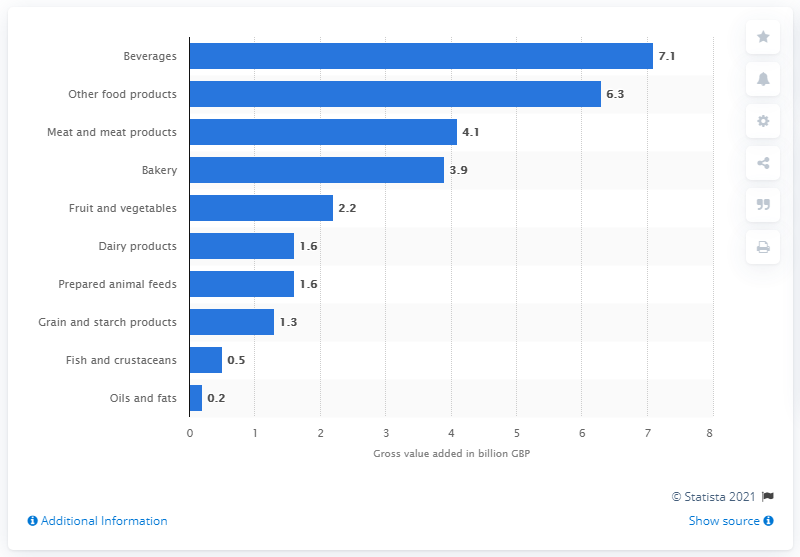Point out several critical features in this image. In 2018, the beverage industry generated a total Gross Value Added (GVA) of 7.1% of the total GVA of the UK economy. In 2018, dairy products accounted for approximately 1.6% of the total food and drink gross value added (GVA) in the United Kingdom. 